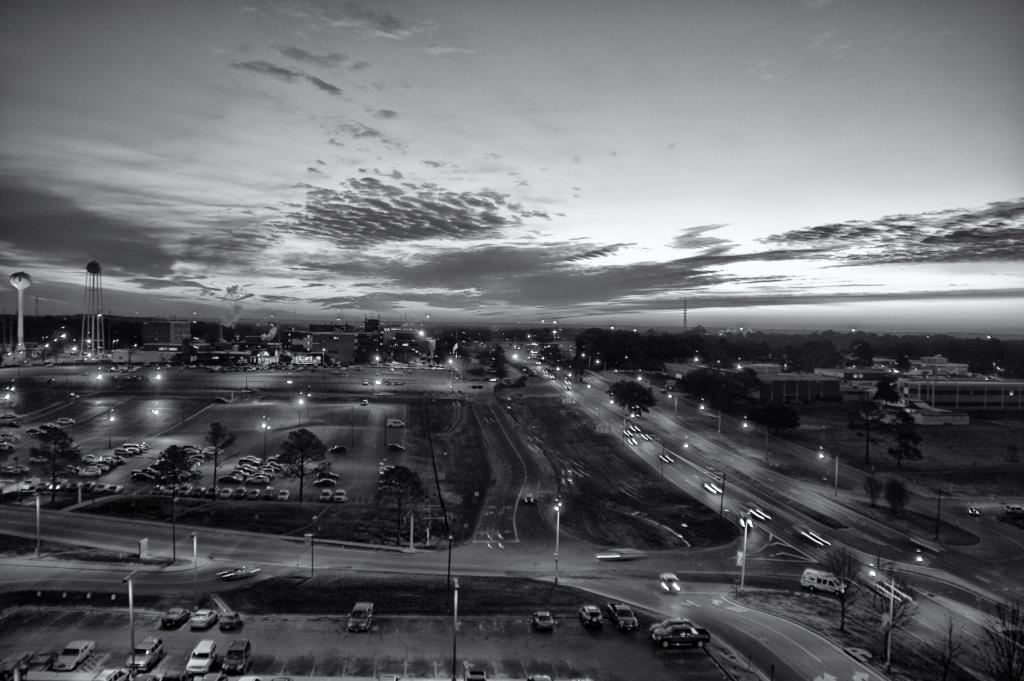What types of objects are present in the image? There are vehicles and poles in the image. What else can be seen in the image besides vehicles and poles? There are trees in the image. What is visible in the background of the image? The sky is visible in the background of the image. How many dinosaurs can be seen in the image? There are no dinosaurs present in the image. What type of wrist accessory is visible on the vehicles in the image? There are no wrist accessories visible on the vehicles in the image. 